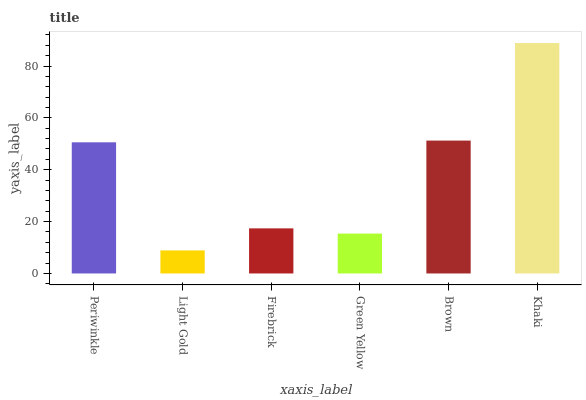Is Light Gold the minimum?
Answer yes or no. Yes. Is Khaki the maximum?
Answer yes or no. Yes. Is Firebrick the minimum?
Answer yes or no. No. Is Firebrick the maximum?
Answer yes or no. No. Is Firebrick greater than Light Gold?
Answer yes or no. Yes. Is Light Gold less than Firebrick?
Answer yes or no. Yes. Is Light Gold greater than Firebrick?
Answer yes or no. No. Is Firebrick less than Light Gold?
Answer yes or no. No. Is Periwinkle the high median?
Answer yes or no. Yes. Is Firebrick the low median?
Answer yes or no. Yes. Is Light Gold the high median?
Answer yes or no. No. Is Brown the low median?
Answer yes or no. No. 